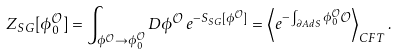<formula> <loc_0><loc_0><loc_500><loc_500>Z _ { S G } [ \phi ^ { \mathcal { O } } _ { 0 } ] = \int _ { \phi ^ { \mathcal { O } } \rightarrow \phi ^ { \mathcal { O } } _ { 0 } } { D \phi ^ { \mathcal { O } } \, e ^ { - S _ { S G } [ \phi ^ { \mathcal { O } } ] } } = \left < e ^ { - \int _ { \partial A d S } { \phi ^ { \mathcal { O } } _ { 0 } \mathcal { O } } } \right > _ { C F T } .</formula> 